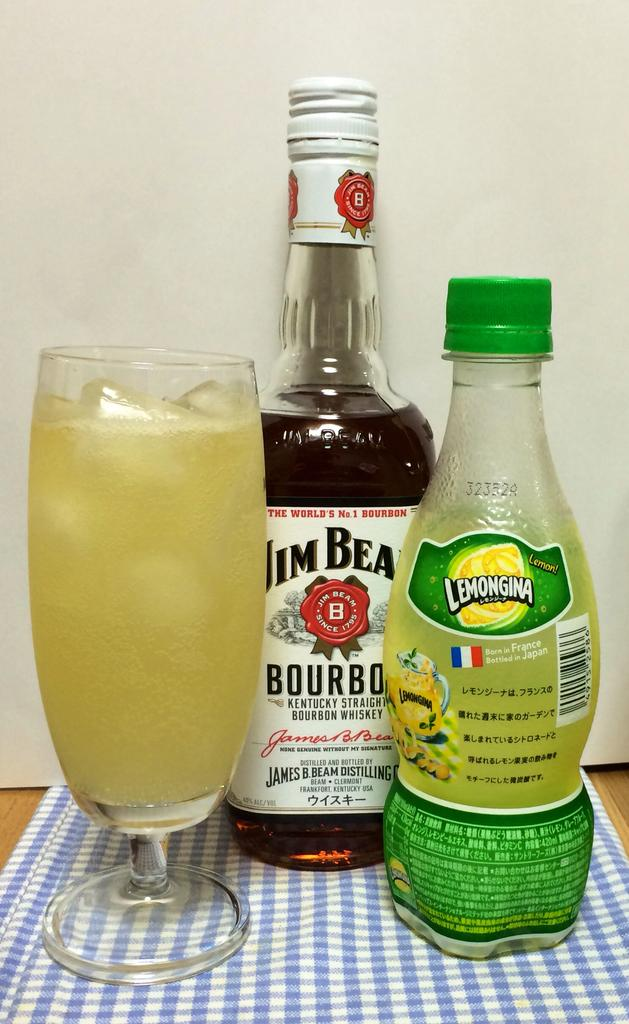<image>
Share a concise interpretation of the image provided. A cocktail of Jim Beam Bourban and Lemongina has been made 